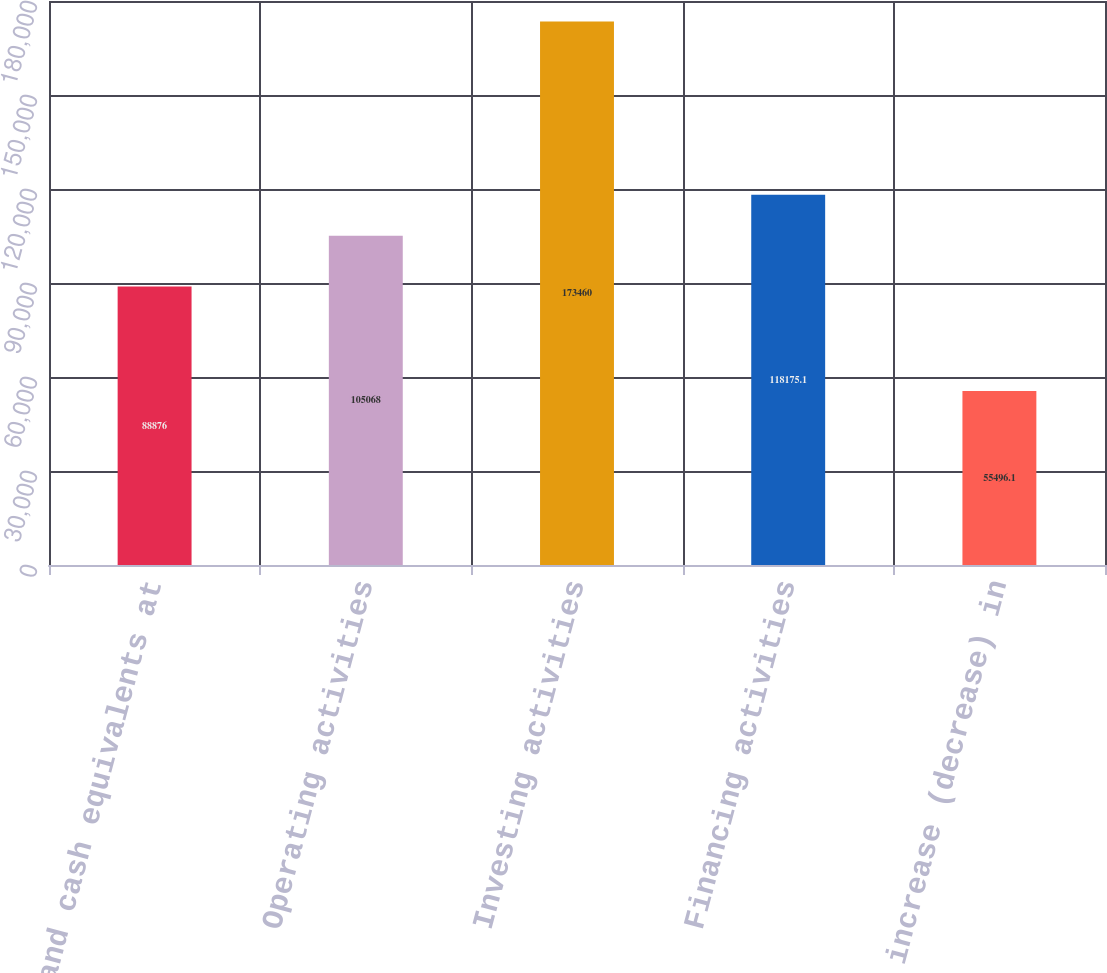Convert chart. <chart><loc_0><loc_0><loc_500><loc_500><bar_chart><fcel>Cash and cash equivalents at<fcel>Operating activities<fcel>Investing activities<fcel>Financing activities<fcel>Net increase (decrease) in<nl><fcel>88876<fcel>105068<fcel>173460<fcel>118175<fcel>55496.1<nl></chart> 